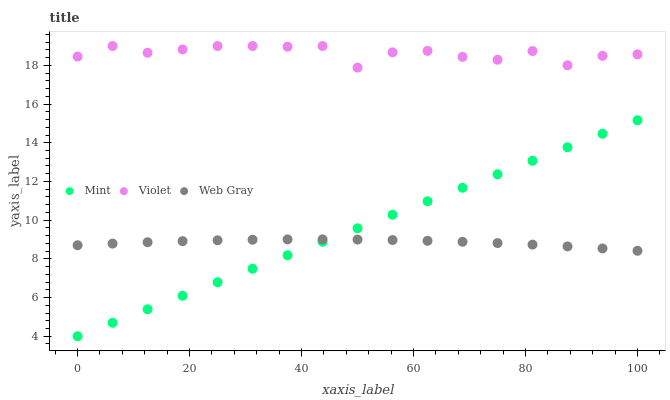Does Web Gray have the minimum area under the curve?
Answer yes or no. Yes. Does Violet have the maximum area under the curve?
Answer yes or no. Yes. Does Mint have the minimum area under the curve?
Answer yes or no. No. Does Mint have the maximum area under the curve?
Answer yes or no. No. Is Mint the smoothest?
Answer yes or no. Yes. Is Violet the roughest?
Answer yes or no. Yes. Is Violet the smoothest?
Answer yes or no. No. Is Mint the roughest?
Answer yes or no. No. Does Mint have the lowest value?
Answer yes or no. Yes. Does Violet have the lowest value?
Answer yes or no. No. Does Violet have the highest value?
Answer yes or no. Yes. Does Mint have the highest value?
Answer yes or no. No. Is Web Gray less than Violet?
Answer yes or no. Yes. Is Violet greater than Web Gray?
Answer yes or no. Yes. Does Mint intersect Web Gray?
Answer yes or no. Yes. Is Mint less than Web Gray?
Answer yes or no. No. Is Mint greater than Web Gray?
Answer yes or no. No. Does Web Gray intersect Violet?
Answer yes or no. No. 